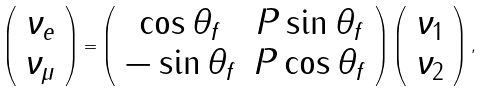Convert formula to latex. <formula><loc_0><loc_0><loc_500><loc_500>\left ( \begin{array} { c } \nu _ { e } \\ \nu _ { \mu } \end{array} \right ) = \left ( \begin{array} { c c } \cos \theta _ { f } & P \sin \theta _ { f } \\ - \sin \theta _ { f } & P \cos \theta _ { f } \end{array} \right ) \left ( \begin{array} { c } \nu _ { 1 } \\ \nu _ { 2 } \end{array} \right ) ,</formula> 